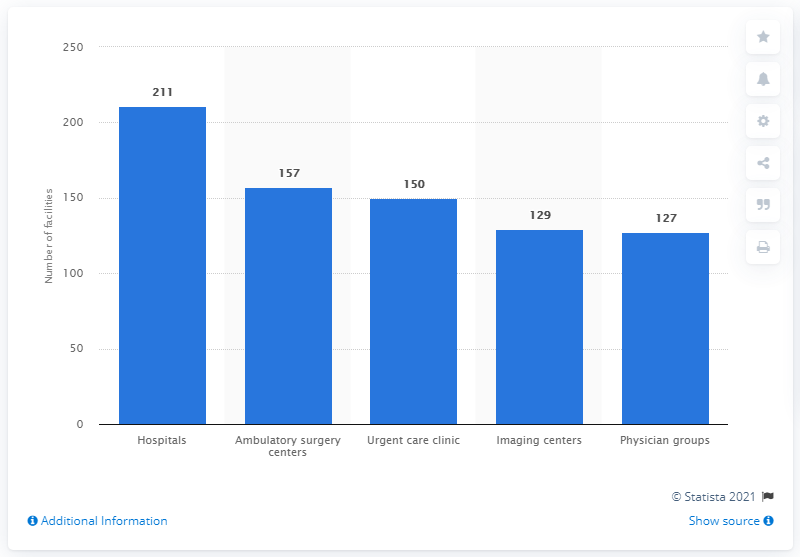Identify some key points in this picture. As of May 2019, HCA Healthcare operated 150 urgent care clinics across the United States. As of May 2019, HCA Healthcare operated 211 hospitals nationwide. 